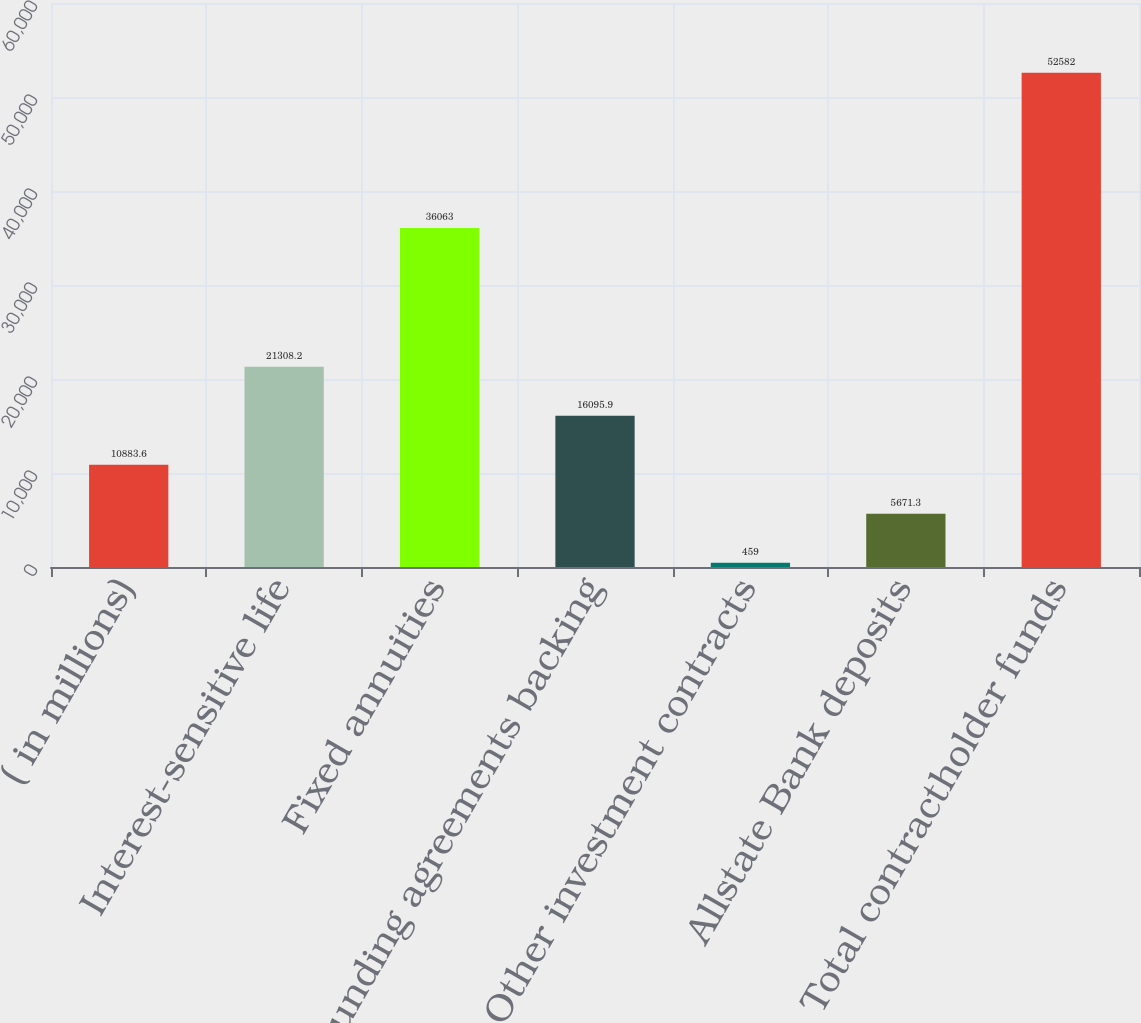Convert chart. <chart><loc_0><loc_0><loc_500><loc_500><bar_chart><fcel>( in millions)<fcel>Interest-sensitive life<fcel>Fixed annuities<fcel>Funding agreements backing<fcel>Other investment contracts<fcel>Allstate Bank deposits<fcel>Total contractholder funds<nl><fcel>10883.6<fcel>21308.2<fcel>36063<fcel>16095.9<fcel>459<fcel>5671.3<fcel>52582<nl></chart> 